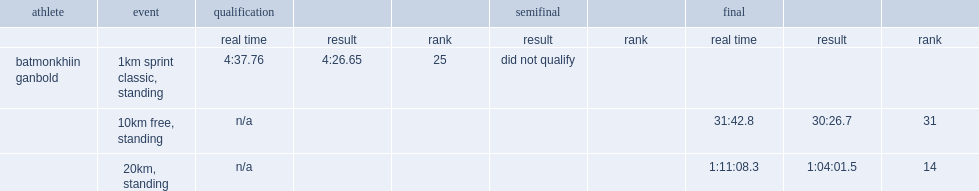What was the result that ganbold got in the 10 kilometer standing freestyle in the final? 30:26.7. 